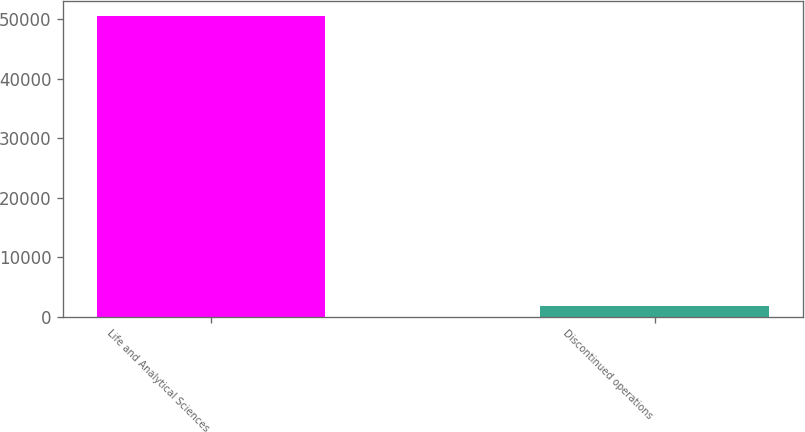Convert chart. <chart><loc_0><loc_0><loc_500><loc_500><bar_chart><fcel>Life and Analytical Sciences<fcel>Discontinued operations<nl><fcel>50575<fcel>1795<nl></chart> 